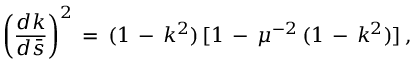<formula> <loc_0><loc_0><loc_500><loc_500>\left ( \frac { d k } { d \bar { s } } \right ) ^ { 2 } \, = \, ( 1 \, - \, k ^ { 2 } ) \, [ 1 \, - \, \mu ^ { - 2 } \, ( 1 \, - \, k ^ { 2 } ) ] \, { , }</formula> 